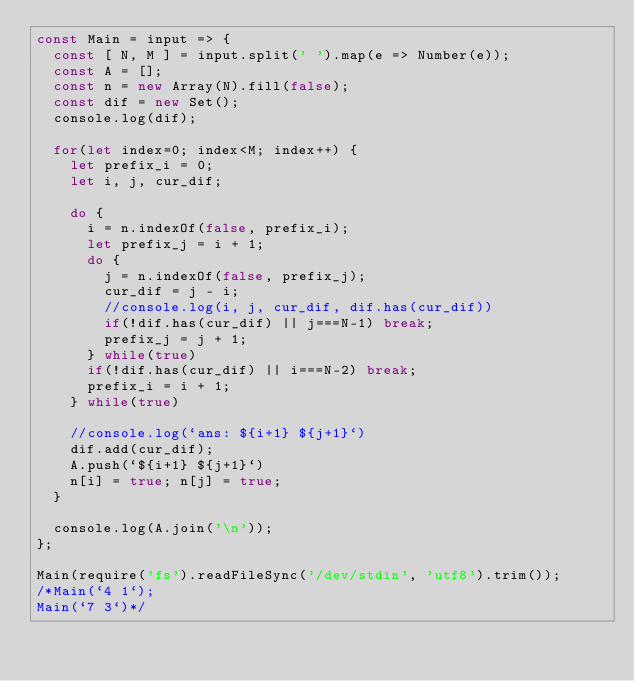<code> <loc_0><loc_0><loc_500><loc_500><_JavaScript_>const Main = input => {
  const [ N, M ] = input.split(' ').map(e => Number(e));
  const A = [];
  const n = new Array(N).fill(false);
  const dif = new Set();
  console.log(dif);

  for(let index=0; index<M; index++) {
    let prefix_i = 0;
    let i, j, cur_dif;    

    do {
      i = n.indexOf(false, prefix_i);
      let prefix_j = i + 1;
      do {
        j = n.indexOf(false, prefix_j);
        cur_dif = j - i;
        //console.log(i, j, cur_dif, dif.has(cur_dif))
        if(!dif.has(cur_dif) || j===N-1) break;
        prefix_j = j + 1;
      } while(true)
      if(!dif.has(cur_dif) || i===N-2) break;
      prefix_i = i + 1;
    } while(true)

    //console.log(`ans: ${i+1} ${j+1}`)
    dif.add(cur_dif);
    A.push(`${i+1} ${j+1}`)
    n[i] = true; n[j] = true;
  }

  console.log(A.join('\n'));
};

Main(require('fs').readFileSync('/dev/stdin', 'utf8').trim());
/*Main(`4 1`);
Main(`7 3`)*/
</code> 